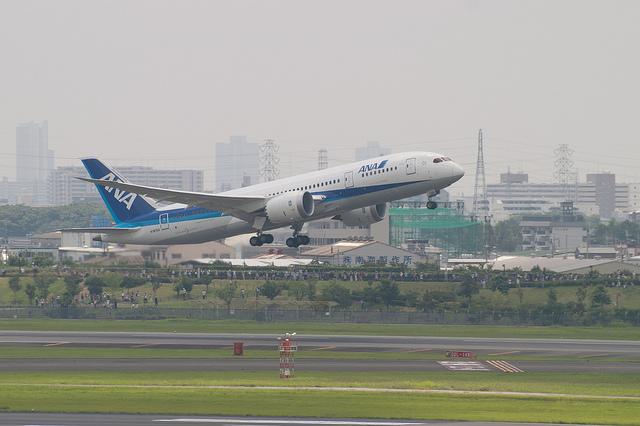Has this plane taken off?
Give a very brief answer. Yes. What is the letter on the roadway sign?
Be succinct. S. Where is the plane flying to?
Be succinct. Atlanta. What is the plane doing?
Give a very brief answer. Taking off. Can the airplane carry more passengers?
Concise answer only. Yes. What is the weather like?
Write a very short answer. Foggy. 